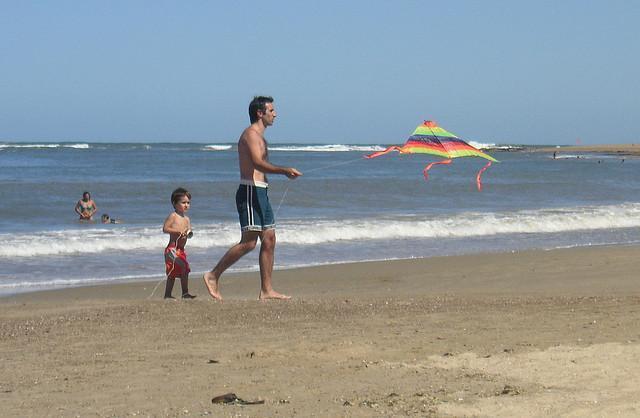How many people are there?
Give a very brief answer. 2. How many cars are parked on the street?
Give a very brief answer. 0. 